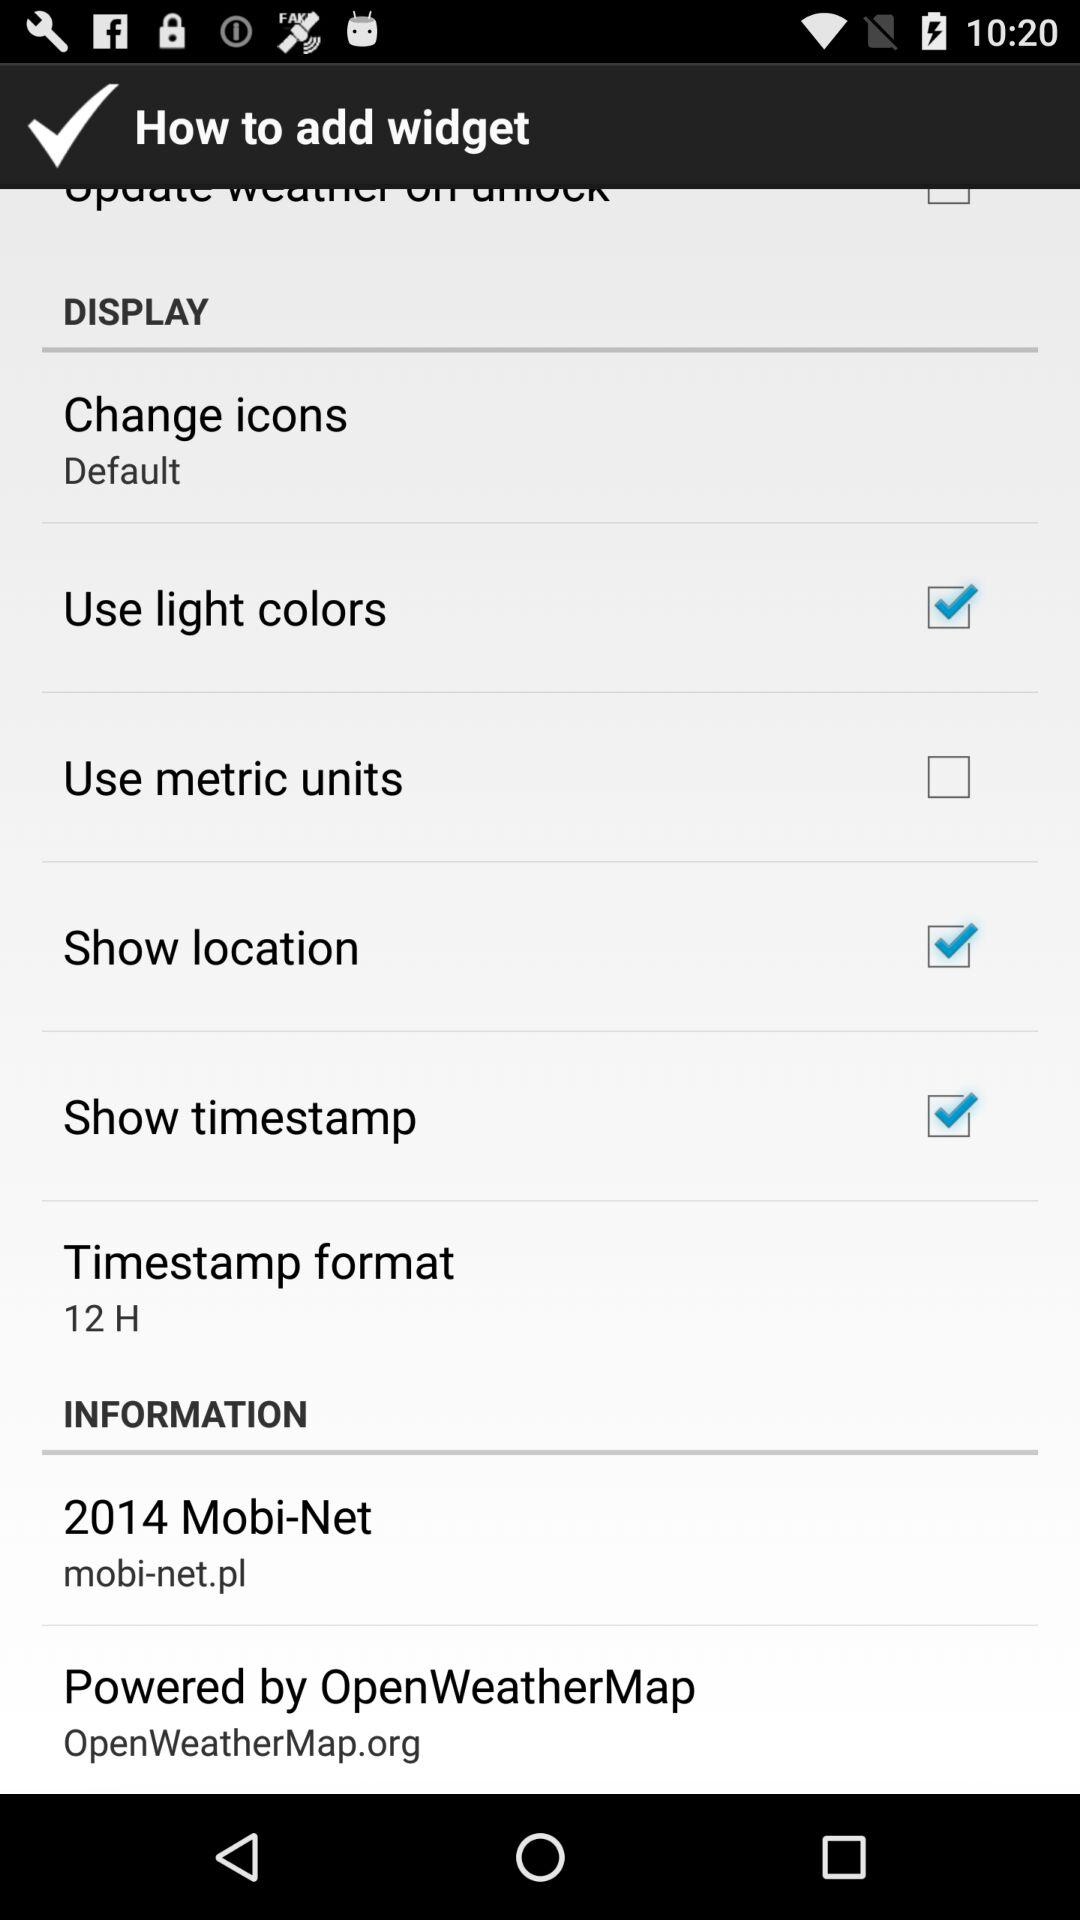What is the status of "Use light colors"? The status of "Use light colors" is "on". 